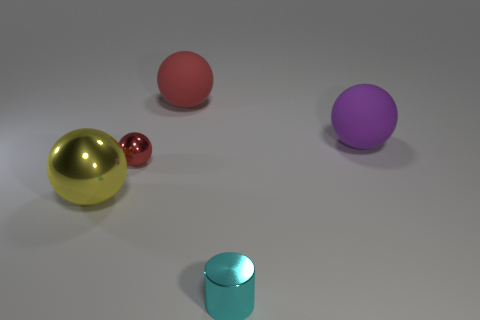Add 3 purple rubber balls. How many objects exist? 8 Subtract all large red rubber spheres. How many spheres are left? 3 Subtract all red balls. How many balls are left? 2 Subtract 0 cyan spheres. How many objects are left? 5 Subtract all spheres. How many objects are left? 1 Subtract 1 cylinders. How many cylinders are left? 0 Subtract all yellow spheres. Subtract all green blocks. How many spheres are left? 3 Subtract all green cylinders. How many brown spheres are left? 0 Subtract all metal objects. Subtract all small yellow cylinders. How many objects are left? 2 Add 3 tiny cyan objects. How many tiny cyan objects are left? 4 